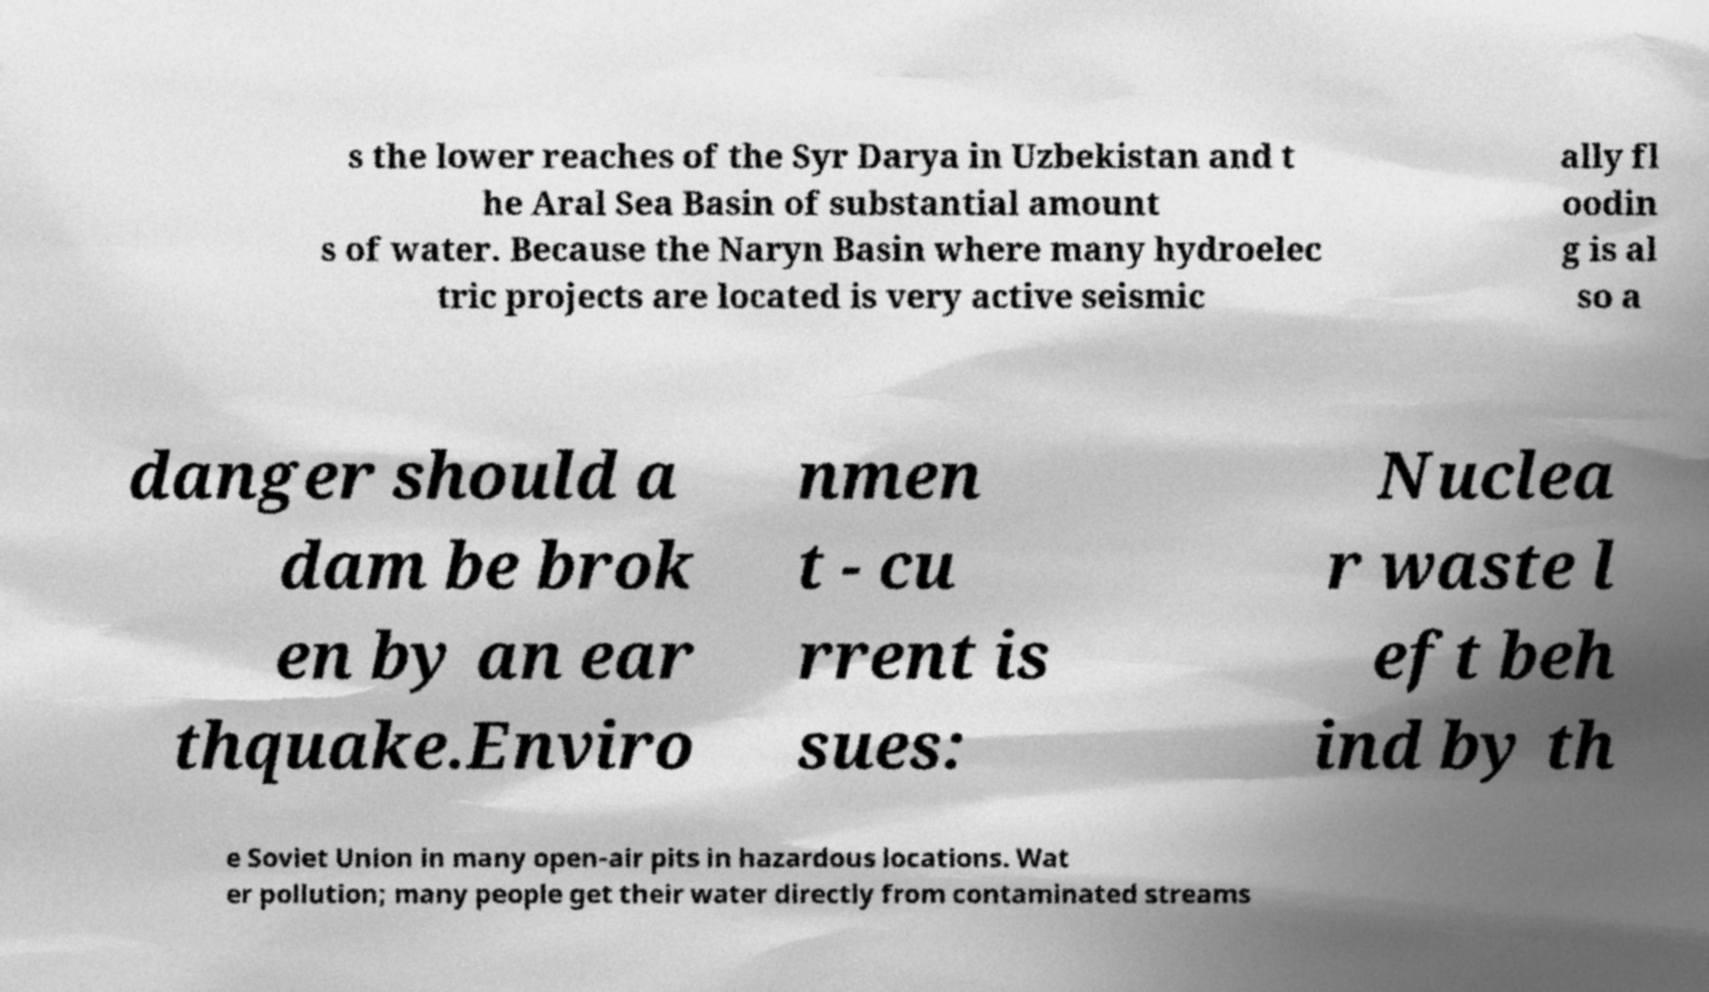What messages or text are displayed in this image? I need them in a readable, typed format. s the lower reaches of the Syr Darya in Uzbekistan and t he Aral Sea Basin of substantial amount s of water. Because the Naryn Basin where many hydroelec tric projects are located is very active seismic ally fl oodin g is al so a danger should a dam be brok en by an ear thquake.Enviro nmen t - cu rrent is sues: Nuclea r waste l eft beh ind by th e Soviet Union in many open-air pits in hazardous locations. Wat er pollution; many people get their water directly from contaminated streams 